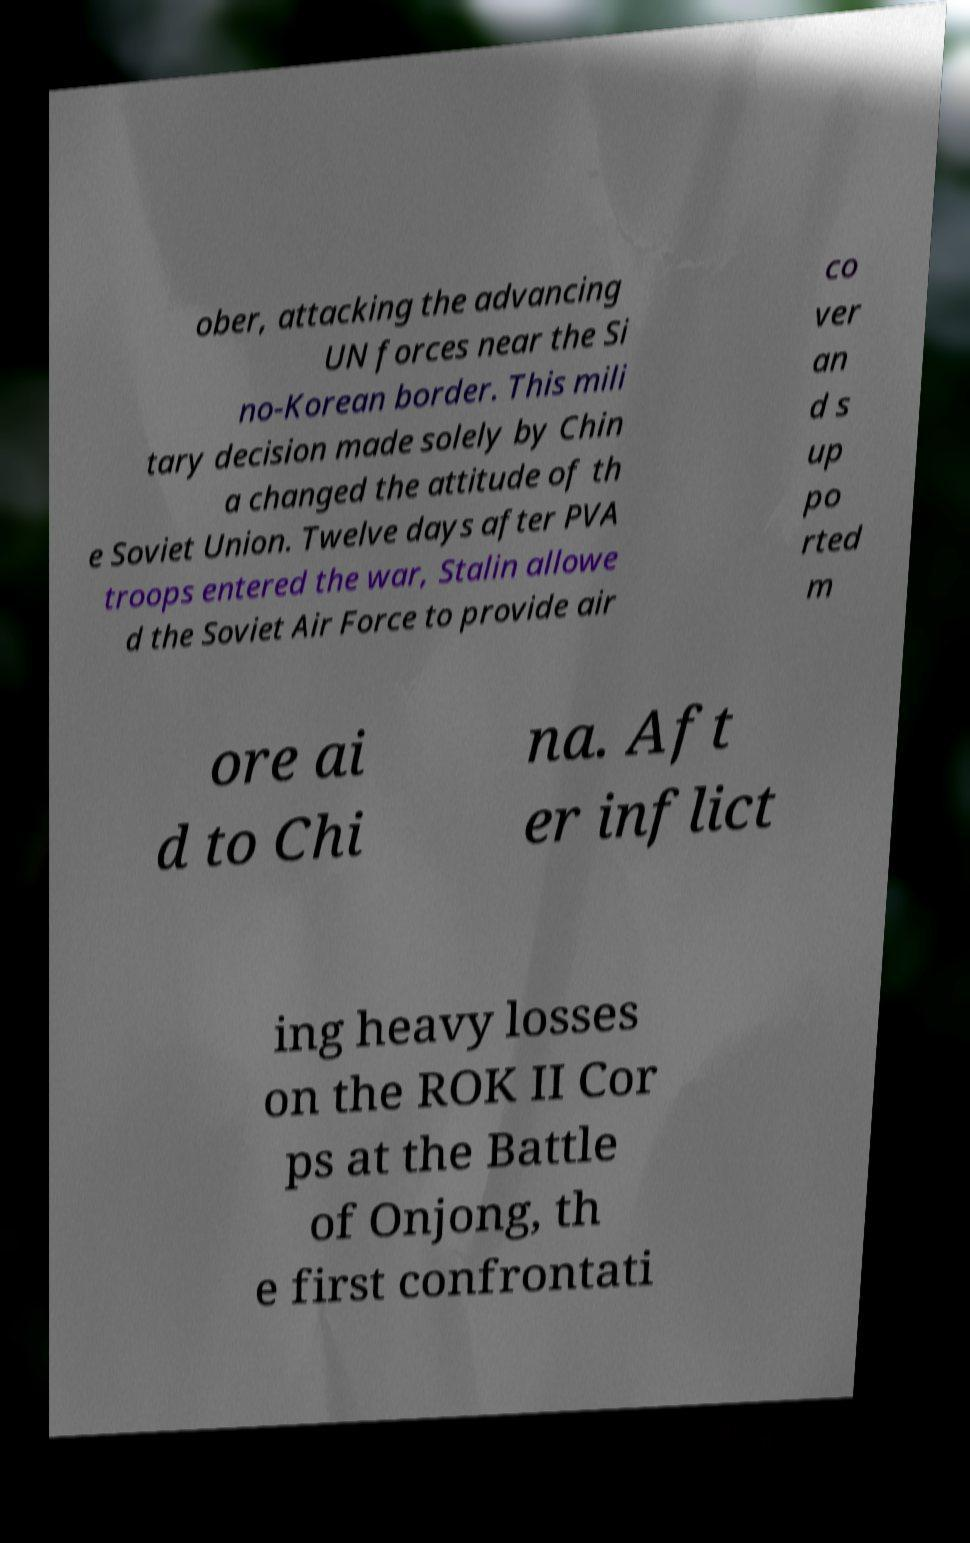For documentation purposes, I need the text within this image transcribed. Could you provide that? ober, attacking the advancing UN forces near the Si no-Korean border. This mili tary decision made solely by Chin a changed the attitude of th e Soviet Union. Twelve days after PVA troops entered the war, Stalin allowe d the Soviet Air Force to provide air co ver an d s up po rted m ore ai d to Chi na. Aft er inflict ing heavy losses on the ROK II Cor ps at the Battle of Onjong, th e first confrontati 